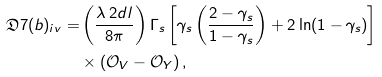Convert formula to latex. <formula><loc_0><loc_0><loc_500><loc_500>\mathfrak { D } 7 ( b ) _ { i v } = & \left ( \frac { \lambda \, 2 d l } { 8 \pi } \right ) \Gamma _ { s } \left [ \gamma _ { s } \left ( \frac { 2 - \gamma _ { s } } { 1 - \gamma _ { s } } \right ) + 2 \ln ( 1 - \gamma _ { s } ) \right ] \\ & \times \left ( \mathcal { O } _ { V } - \mathcal { O } _ { Y } \right ) ,</formula> 